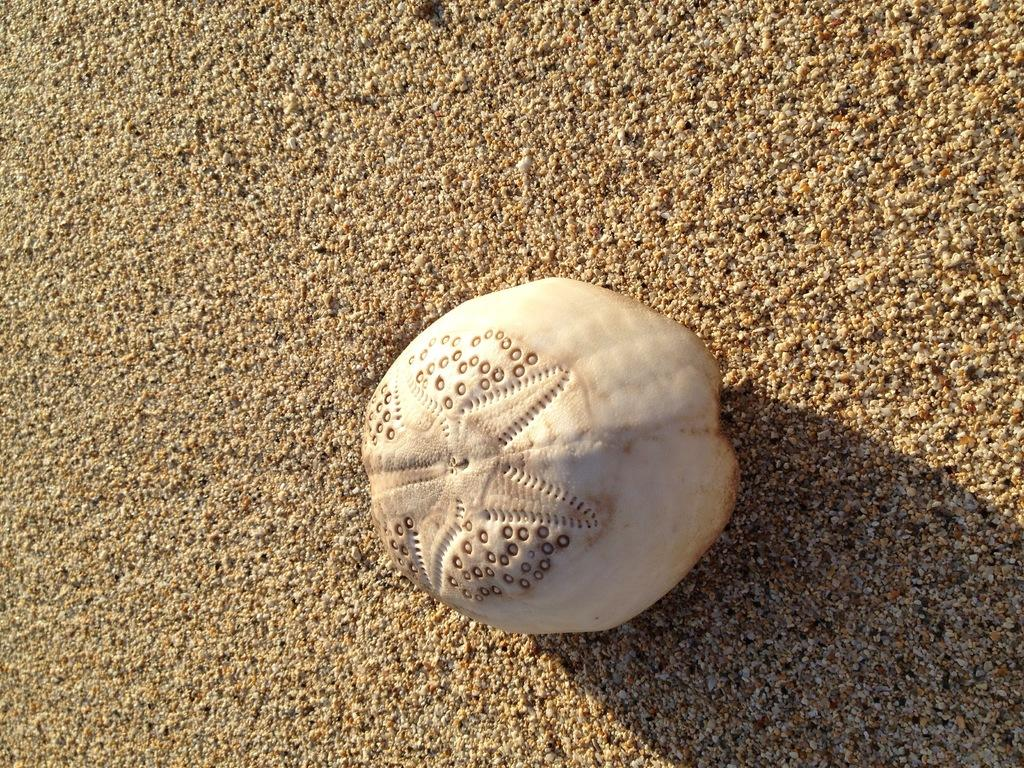What is the main subject in the image that has a white color? There is a white color thing in the image. Where is the white color thing located? The white color thing is on the sand. How many lawyers are present in the image? There is no mention of lawyers in the image, so it is impossible to determine their presence or number. 